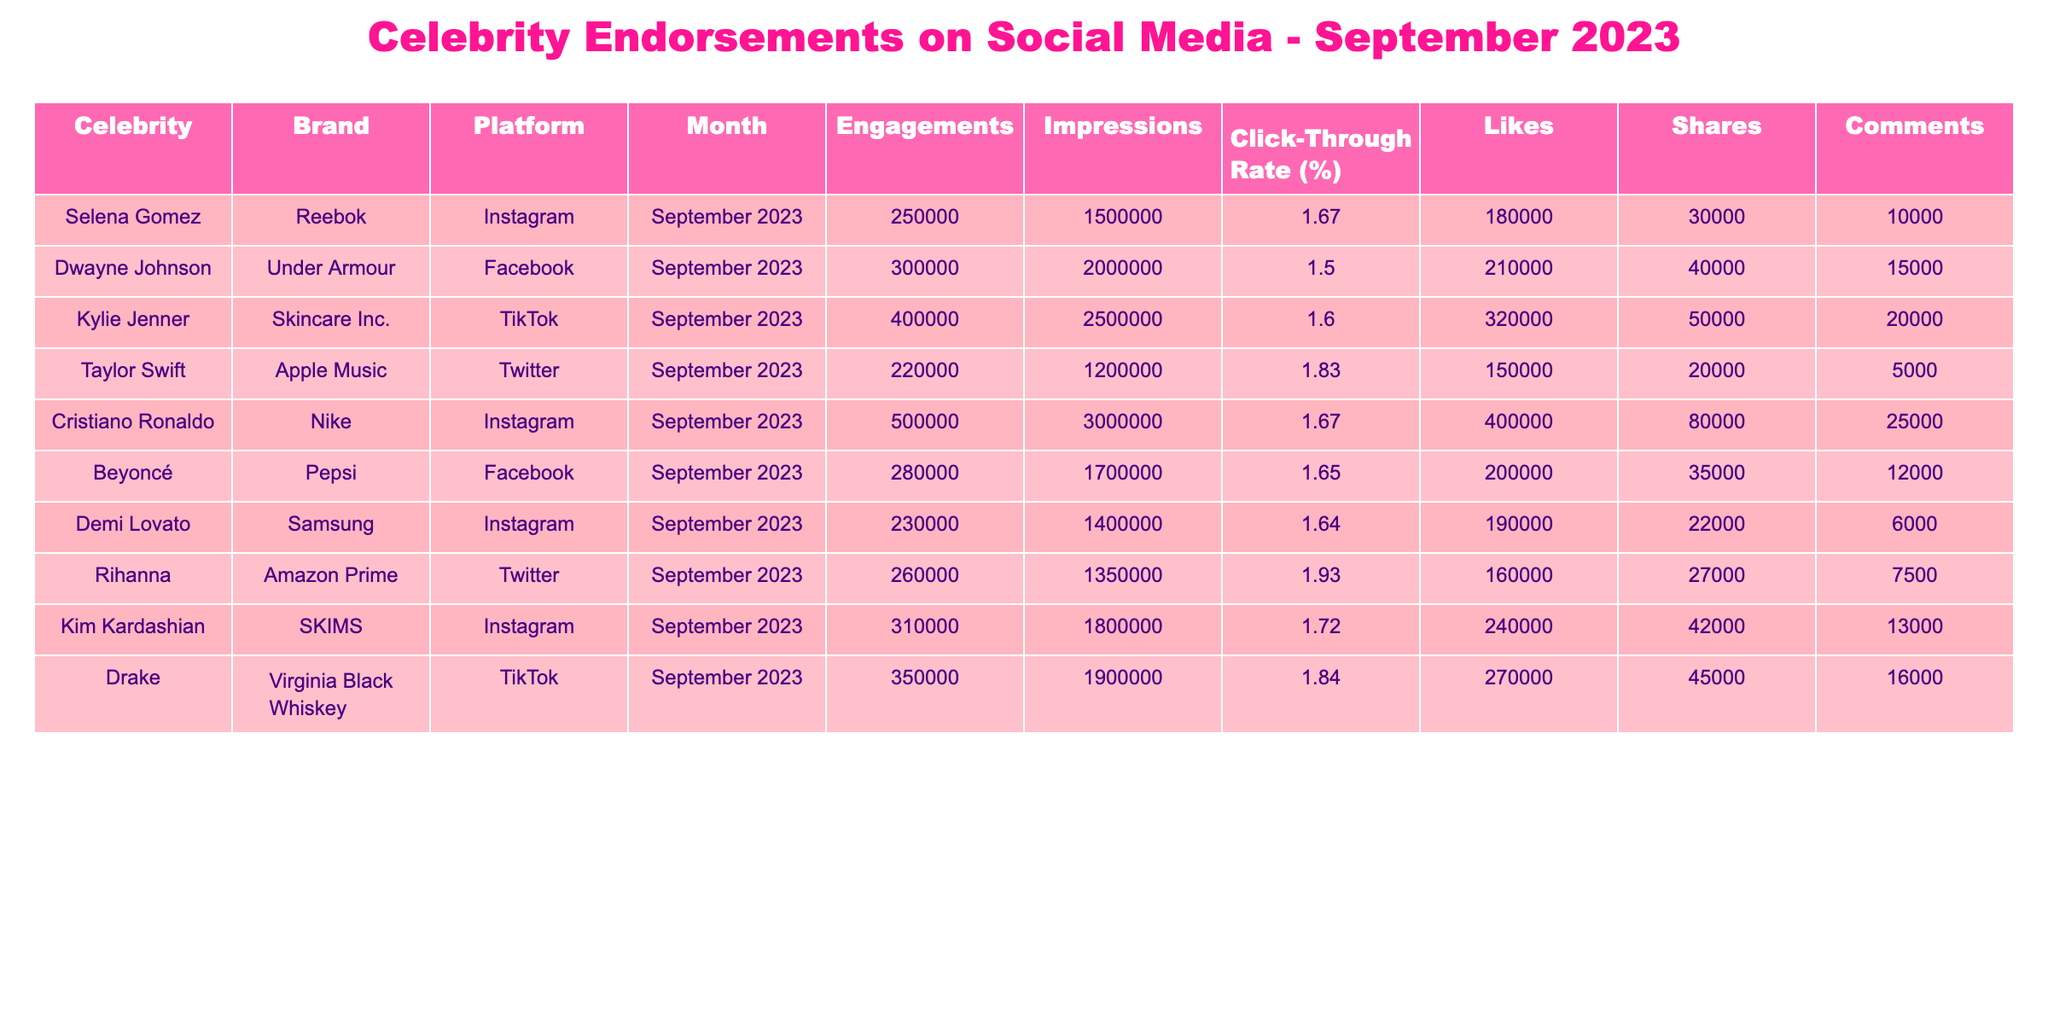What is the highest engagement achieved by a celebrity on Instagram? Looking at the "Engagements" column, Cristiano Ronaldo has the highest engagement with 500,000 for Nike on Instagram in September 2023.
Answer: 500,000 Which brand had the lowest engagement in the table? Checking the "Engagements" column, the brand with the lowest engagement is Demi Lovato with 230,000 for Samsung on Instagram in September 2023.
Answer: 230,000 What is the total number of engagements recorded for all celebrities on TikTok? The TikTok engagements are 400,000 for Kylie Jenner and 350,000 for Drake. Their total is 400,000 + 350,000 = 750,000.
Answer: 750,000 Did any celebrity have a Click-Through Rate above 1.8%? Reviewing the "Click-Through Rate (%)" column, Rihanna with 1.93% for Amazon Prime and Drake with 1.84% for Virginia Black Whiskey both had a Click-Through Rate above 1.8%.
Answer: Yes What is the average Click-Through Rate across all celebrities in the table? Adding all the Click-Through Rates: 1.67 + 1.50 + 1.60 + 1.83 + 1.67 + 1.65 + 1.64 + 1.93 + 1.72 + 1.84 = 16.51. There are 10 values, so average = 16.51 / 10 = 1.651.
Answer: 1.651 Which platform had the most total impressions combined? Calculating impressions: Instagram has (1,500,000 + 3,000,000 + 1,400,000 + 1,800,000) = 7,700,000; Facebook has (2,000,000 + 1,700,000) = 3,700,000; TikTok has (2,500,000 + 1,900,000) = 4,400,000; Twitter has (1,200,000 + 1,350,000) = 2,550,000. Instagram has the highest with 7,700,000 impressions.
Answer: Instagram Who had more shares, Kim Kardashian or Dwayne Johnson? Kim Kardashian has 42,000 shares and Dwayne Johnson has 40,000 shares. Comparing the two, Kim Kardashian has more shares than Dwayne Johnson.
Answer: Kim Kardashian How many total comments were made on all celebrity posts for September 2023? Summing the comments: 10,000 + 15,000 + 20,000 + 5,000 + 25,000 + 12,000 + 6,000 + 7,500 + 13,000 + 16,000 = 129,500 total comments.
Answer: 129,500 Which celebrity had the best engagement rate based on impressions? Engagement rate is calculated as (Engagements/Impressions)*100. For Cristiano Ronaldo: (500,000/3,000,000)*100 = 16.67%; for Kylie Jenner: (400,000/2,500,000)*100 = 16%; the highest is Cristiano Ronaldo at 16.67%.
Answer: Cristiano Ronaldo Based on the data, is there a celebrity who achieved at least 1.8% Click-Through Rate and also had more than 400,000 engagements? Checking the metrics, Cristiano Ronaldo meets this criteria with 500,000 engagements and a Click-Through Rate of 1.67%. No other celebrities meet both conditions.
Answer: No 